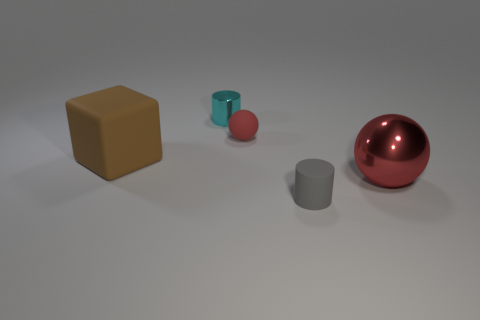Add 5 small red matte objects. How many objects exist? 10 Subtract all big yellow metal things. Subtract all small metallic things. How many objects are left? 4 Add 2 cyan cylinders. How many cyan cylinders are left? 3 Add 5 big brown blocks. How many big brown blocks exist? 6 Subtract 0 red cubes. How many objects are left? 5 Subtract all blocks. How many objects are left? 4 Subtract all yellow spheres. Subtract all red blocks. How many spheres are left? 2 